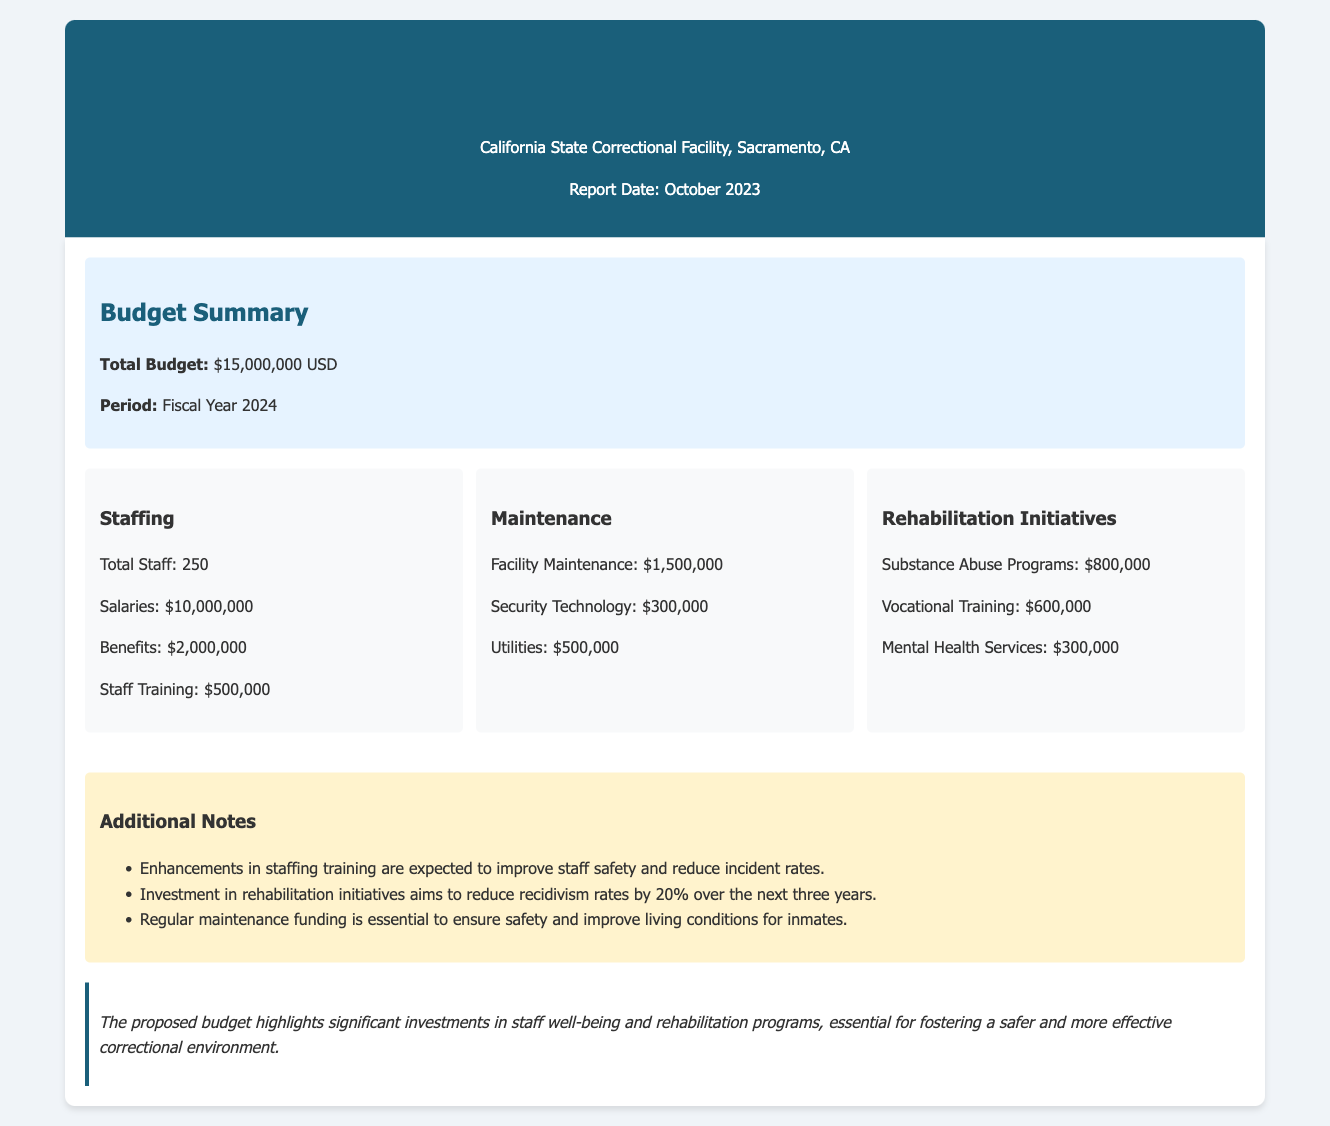What is the total budget? The total budget is explicitly stated in the document as $15,000,000 USD.
Answer: $15,000,000 USD What is the budget period? The budget period specified in the document is for the fiscal year 2024.
Answer: Fiscal Year 2024 How much is allocated for staff salaries? The document lists staff salaries expenditure as $10,000,000.
Answer: $10,000,000 What amount is budgeted for substance abuse programs? According to the document, the budget for substance abuse programs is $800,000.
Answer: $800,000 How many staff members are there in total? The total number of staff mentioned in the document is 250.
Answer: 250 What is the expected reduction in recidivism rates? The document states that the investment in rehabilitation initiatives aims to reduce recidivism rates by 20%.
Answer: 20% What is the total amount allocated to maintenance? The total amount for maintenance is calculated by adding all maintenance-related expenses, which is $1,500,000 + $300,000 + $500,000 = $2,300,000.
Answer: $2,300,000 What portion of the budget is allocated to benefits? The document specifically states that the amount allocated to benefits is $2,000,000.
Answer: $2,000,000 What is outlined in the additional notes regarding staffing? The document mentions that enhancements in staffing training are expected to improve staff safety and reduce incident rates.
Answer: Improve staff safety and reduce incident rates 